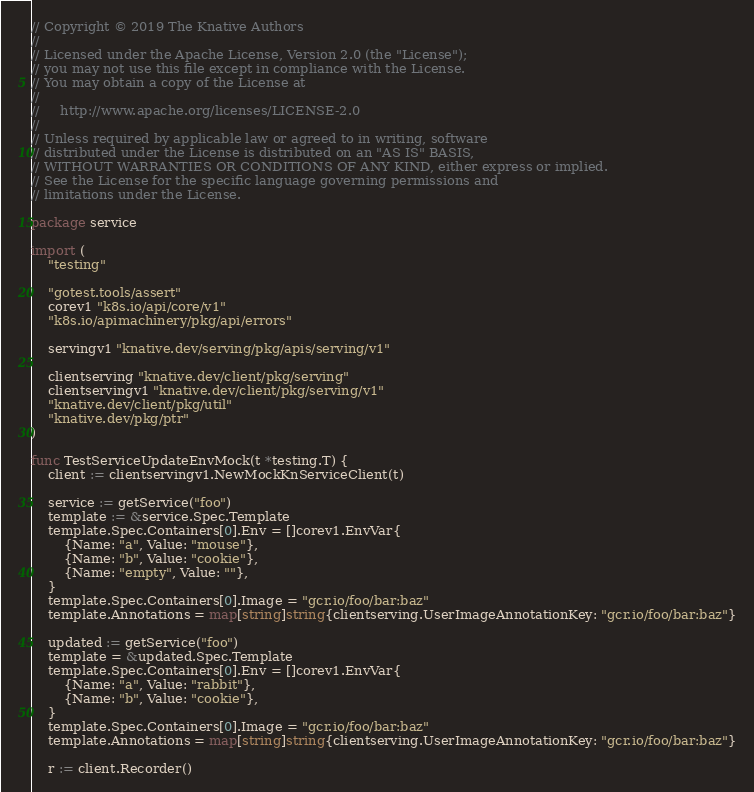Convert code to text. <code><loc_0><loc_0><loc_500><loc_500><_Go_>// Copyright © 2019 The Knative Authors
//
// Licensed under the Apache License, Version 2.0 (the "License");
// you may not use this file except in compliance with the License.
// You may obtain a copy of the License at
//
//     http://www.apache.org/licenses/LICENSE-2.0
//
// Unless required by applicable law or agreed to in writing, software
// distributed under the License is distributed on an "AS IS" BASIS,
// WITHOUT WARRANTIES OR CONDITIONS OF ANY KIND, either express or implied.
// See the License for the specific language governing permissions and
// limitations under the License.

package service

import (
	"testing"

	"gotest.tools/assert"
	corev1 "k8s.io/api/core/v1"
	"k8s.io/apimachinery/pkg/api/errors"

	servingv1 "knative.dev/serving/pkg/apis/serving/v1"

	clientserving "knative.dev/client/pkg/serving"
	clientservingv1 "knative.dev/client/pkg/serving/v1"
	"knative.dev/client/pkg/util"
	"knative.dev/pkg/ptr"
)

func TestServiceUpdateEnvMock(t *testing.T) {
	client := clientservingv1.NewMockKnServiceClient(t)

	service := getService("foo")
	template := &service.Spec.Template
	template.Spec.Containers[0].Env = []corev1.EnvVar{
		{Name: "a", Value: "mouse"},
		{Name: "b", Value: "cookie"},
		{Name: "empty", Value: ""},
	}
	template.Spec.Containers[0].Image = "gcr.io/foo/bar:baz"
	template.Annotations = map[string]string{clientserving.UserImageAnnotationKey: "gcr.io/foo/bar:baz"}

	updated := getService("foo")
	template = &updated.Spec.Template
	template.Spec.Containers[0].Env = []corev1.EnvVar{
		{Name: "a", Value: "rabbit"},
		{Name: "b", Value: "cookie"},
	}
	template.Spec.Containers[0].Image = "gcr.io/foo/bar:baz"
	template.Annotations = map[string]string{clientserving.UserImageAnnotationKey: "gcr.io/foo/bar:baz"}

	r := client.Recorder()</code> 